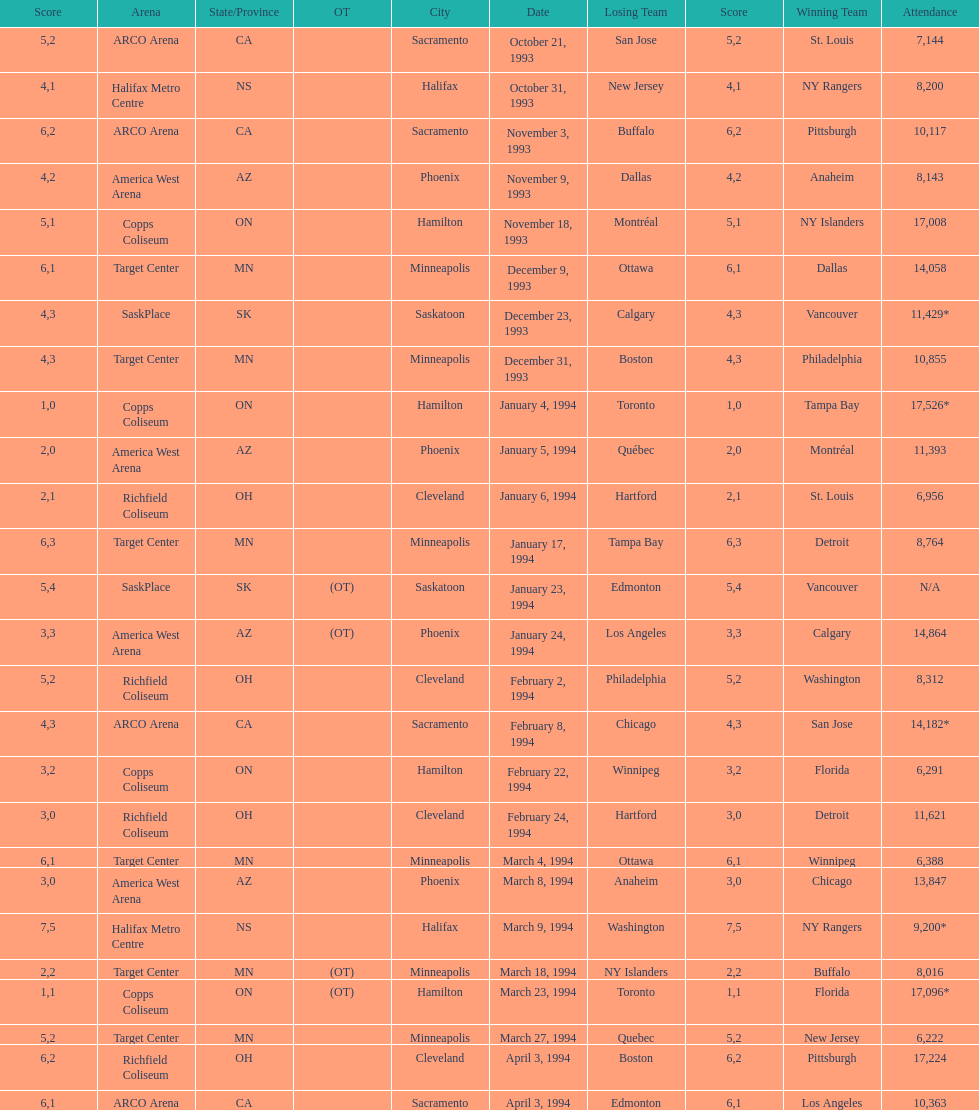Who won the game the day before the january 5, 1994 game? Tampa Bay. 